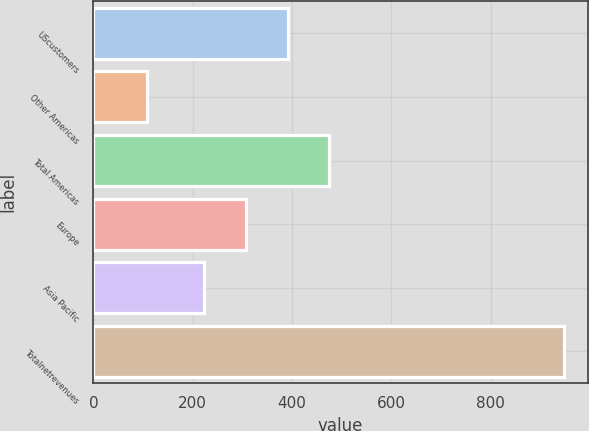Convert chart. <chart><loc_0><loc_0><loc_500><loc_500><bar_chart><fcel>UScustomers<fcel>Other Americas<fcel>Total Americas<fcel>Europe<fcel>Asia Pacific<fcel>Totalnetrevenues<nl><fcel>390.8<fcel>108.5<fcel>474.7<fcel>306.9<fcel>223<fcel>947.5<nl></chart> 